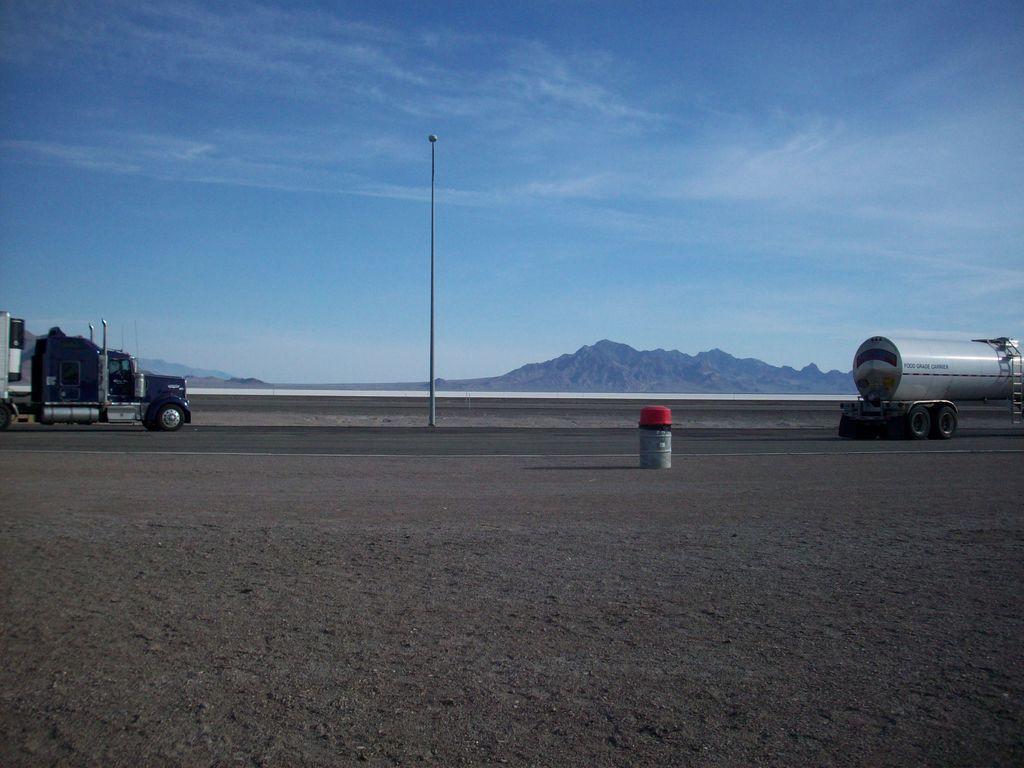Describe this image in one or two sentences. In this picture we can see there are two vehicles on the road. In between the vehicles there is a pole. Behind the vehicles there are hills and the sky. In front of the vehicles there is an object. 